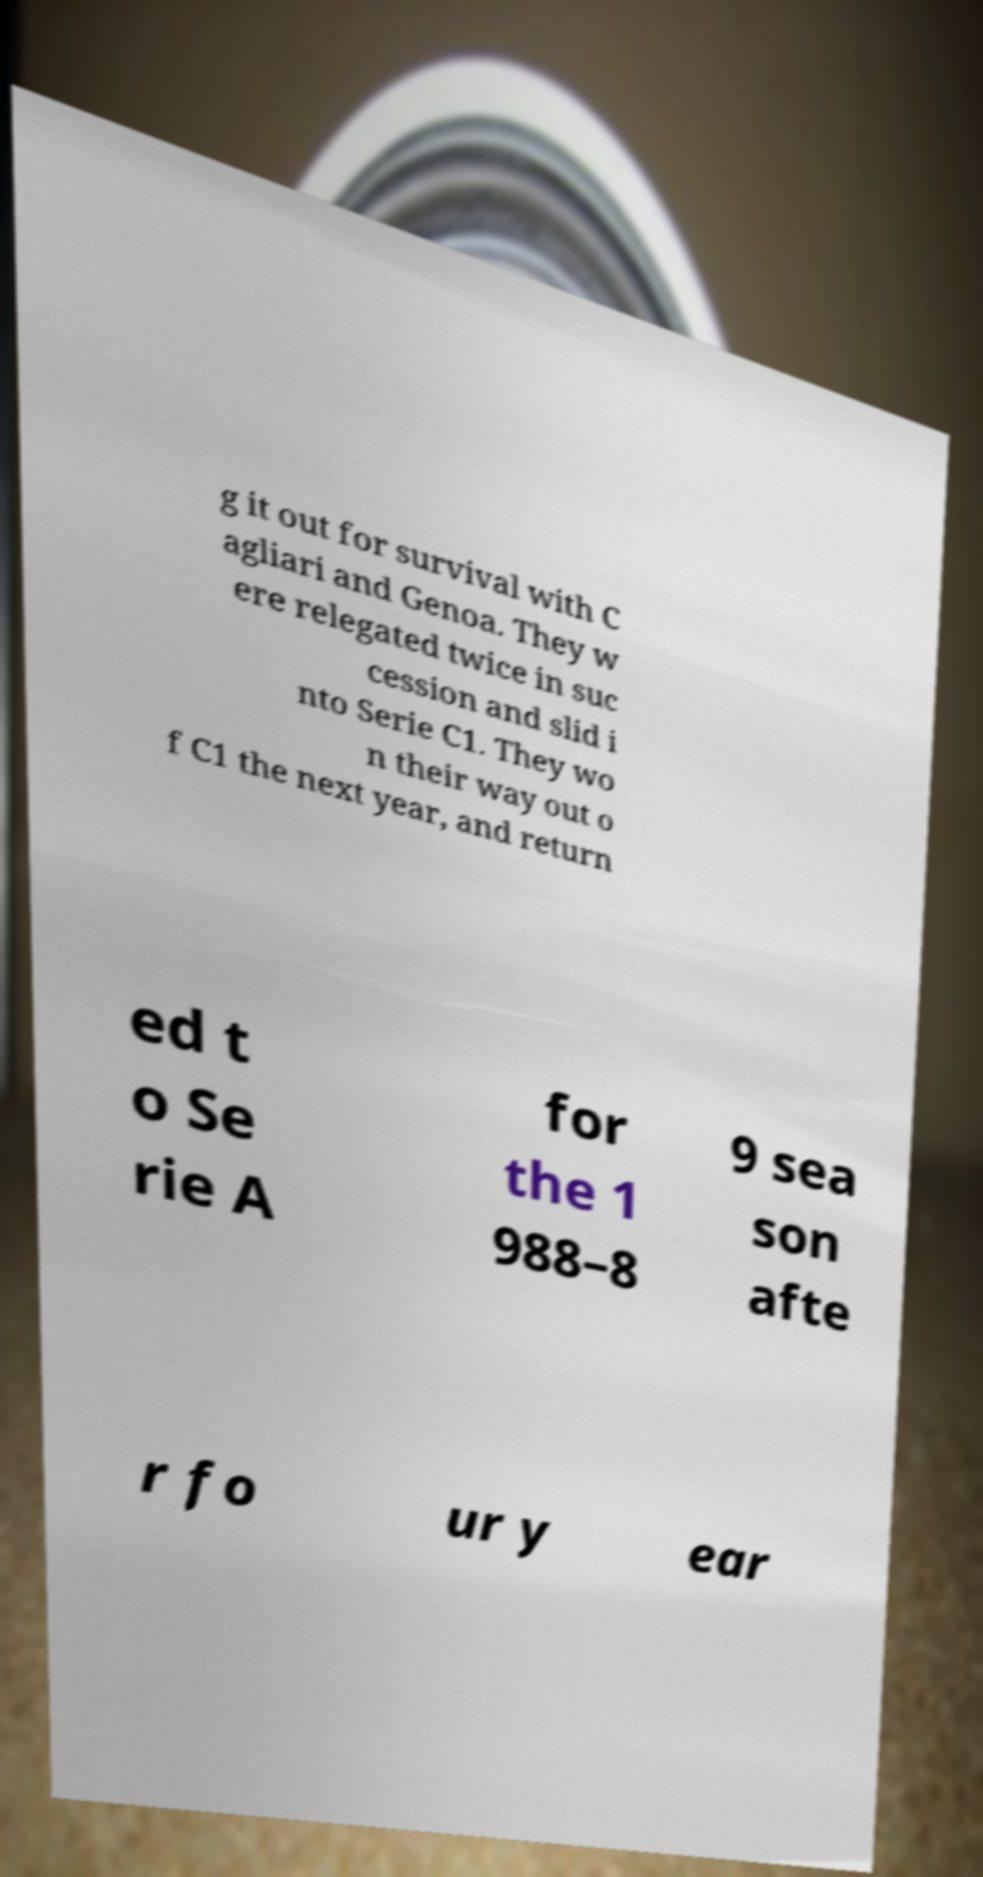For documentation purposes, I need the text within this image transcribed. Could you provide that? g it out for survival with C agliari and Genoa. They w ere relegated twice in suc cession and slid i nto Serie C1. They wo n their way out o f C1 the next year, and return ed t o Se rie A for the 1 988–8 9 sea son afte r fo ur y ear 